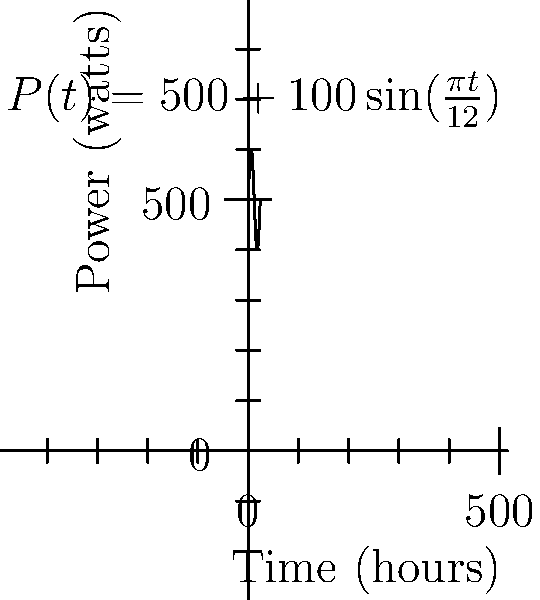An electrical device's power consumption over a 24-hour period is modeled by the function $P(t) = 500 + 100\sin(\frac{\pi t}{12})$ watts, where $t$ is the time in hours. Calculate the total energy consumed by the device in kilowatt-hours (kWh) over this 24-hour period. To solve this problem, we need to follow these steps:

1) The energy consumed is the integral of power over time. We need to integrate $P(t)$ from $t=0$ to $t=24$.

2) Set up the integral:
   $$E = \int_0^{24} P(t) dt = \int_0^{24} (500 + 100\sin(\frac{\pi t}{12})) dt$$

3) Split the integral:
   $$E = \int_0^{24} 500 dt + \int_0^{24} 100\sin(\frac{\pi t}{12}) dt$$

4) Solve the first part:
   $$\int_0^{24} 500 dt = 500t \Big|_0^{24} = 500 \cdot 24 - 500 \cdot 0 = 12000$$

5) Solve the second part:
   $$\int_0^{24} 100\sin(\frac{\pi t}{12}) dt = -\frac{1200}{\pi} \cos(\frac{\pi t}{12}) \Big|_0^{24}$$
   $$= -\frac{1200}{\pi} [\cos(2\pi) - \cos(0)] = -\frac{1200}{\pi} [1 - 1] = 0$$

6) Sum the results:
   $$E = 12000 + 0 = 12000 \text{ watt-hours}$$

7) Convert to kilowatt-hours:
   $$E = 12000 \text{ Wh} \cdot \frac{1 \text{ kWh}}{1000 \text{ Wh}} = 12 \text{ kWh}$$
Answer: 12 kWh 